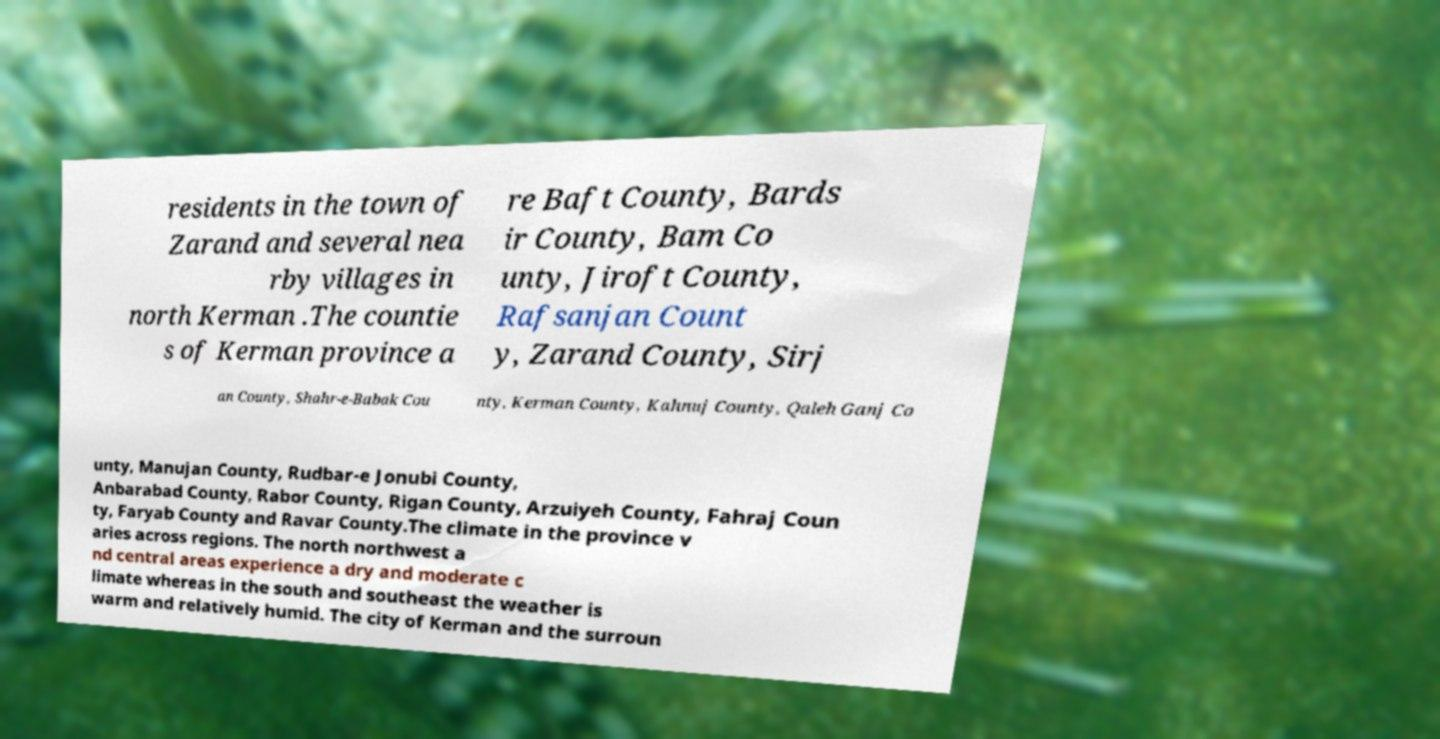Please identify and transcribe the text found in this image. residents in the town of Zarand and several nea rby villages in north Kerman .The countie s of Kerman province a re Baft County, Bards ir County, Bam Co unty, Jiroft County, Rafsanjan Count y, Zarand County, Sirj an County, Shahr-e-Babak Cou nty, Kerman County, Kahnuj County, Qaleh Ganj Co unty, Manujan County, Rudbar-e Jonubi County, Anbarabad County, Rabor County, Rigan County, Arzuiyeh County, Fahraj Coun ty, Faryab County and Ravar County.The climate in the province v aries across regions. The north northwest a nd central areas experience a dry and moderate c limate whereas in the south and southeast the weather is warm and relatively humid. The city of Kerman and the surroun 